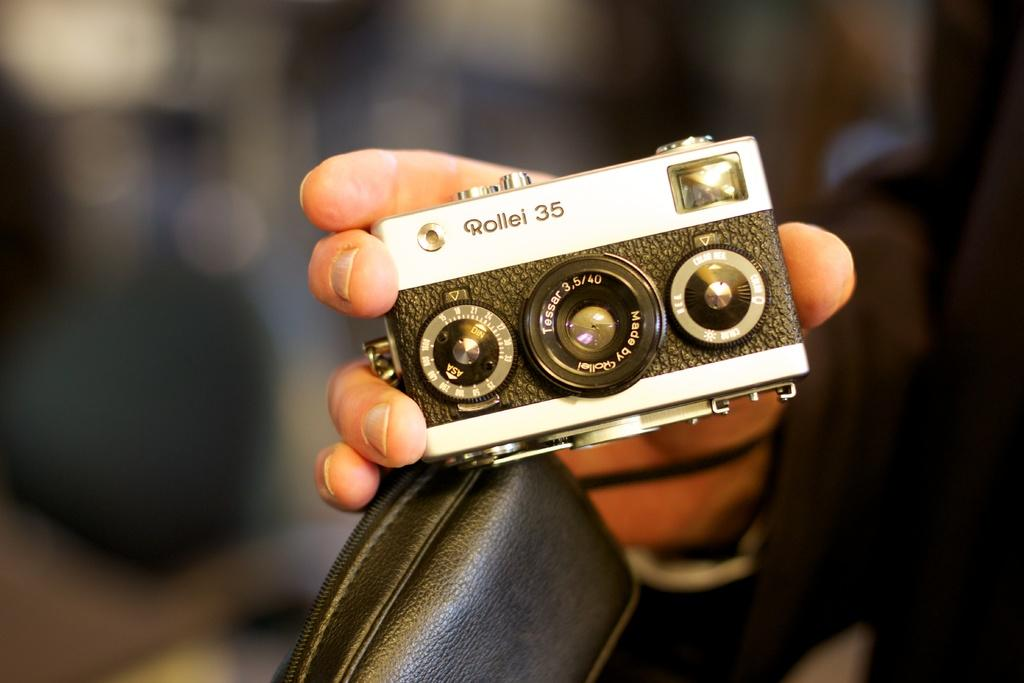<image>
Present a compact description of the photo's key features. Person holding a camera which says "Rollei" on the top. 